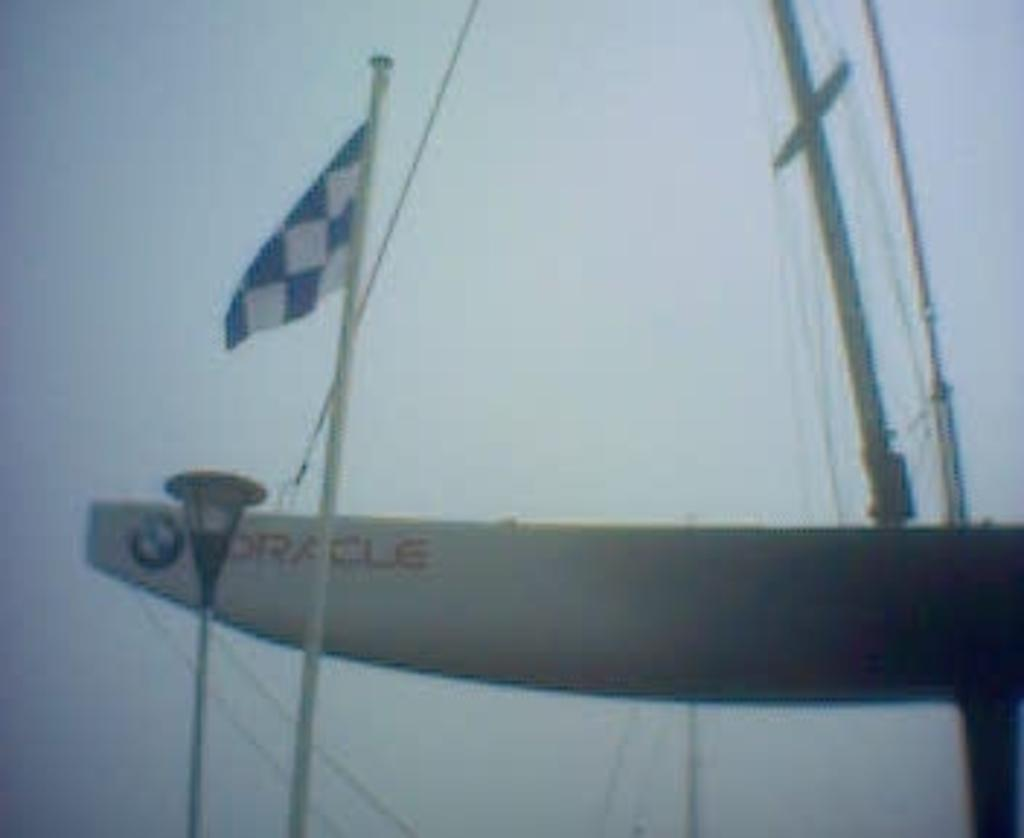What is the main object in the image that represents a symbol or country? There is a flag in the image. What type of structure can be seen in the image? There is a light pole in the image. What color is the object mentioned in the image? There is a white color object in the image. What is the long, flexible object in the image? There is a rope in the image. Where is the father sitting on the throne in the image? There is no father or throne present in the image. How does the earthquake affect the flag in the image? There is no earthquake present in the image, so it cannot affect the flag. 